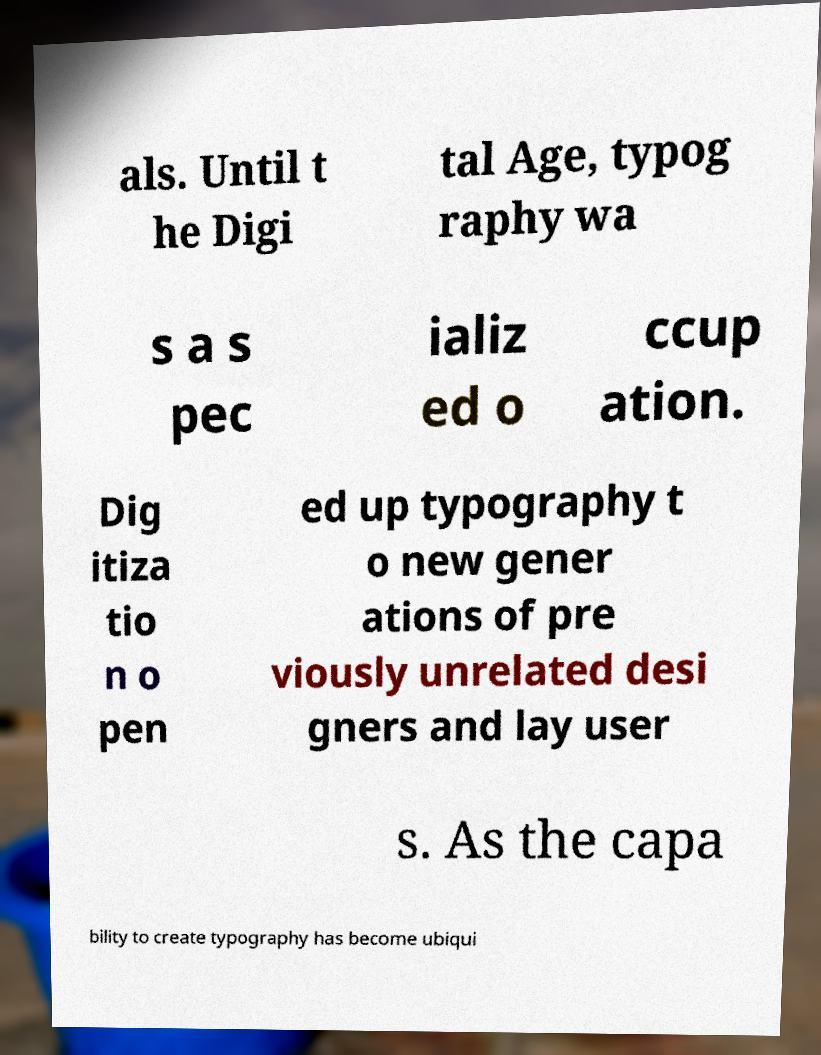Can you accurately transcribe the text from the provided image for me? als. Until t he Digi tal Age, typog raphy wa s a s pec ializ ed o ccup ation. Dig itiza tio n o pen ed up typography t o new gener ations of pre viously unrelated desi gners and lay user s. As the capa bility to create typography has become ubiqui 